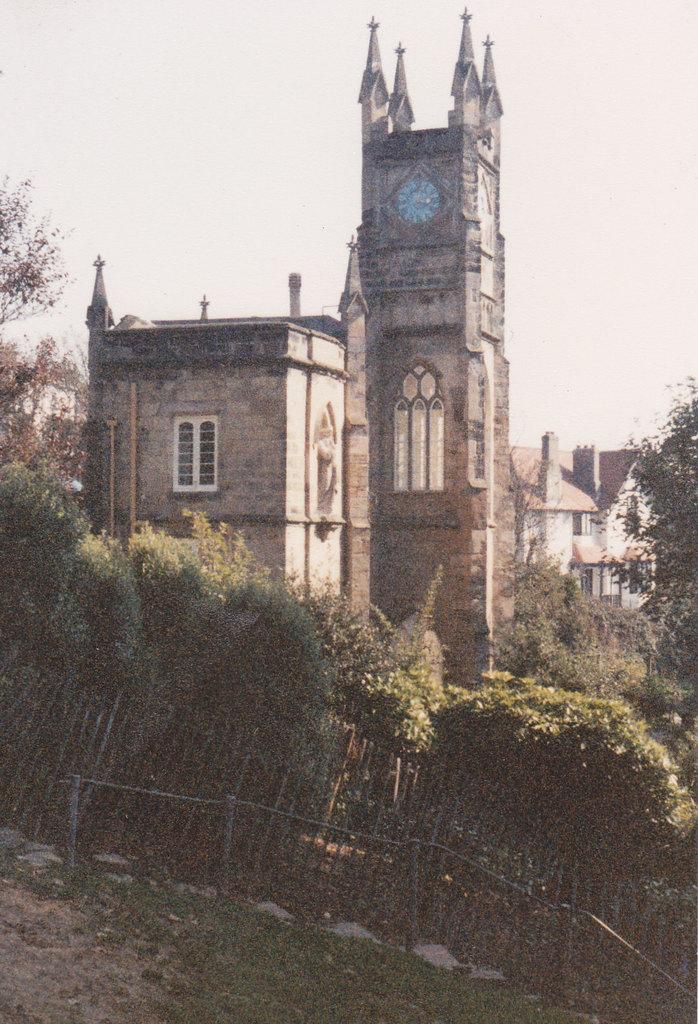What type of structures can be seen in the image? There are buildings in the image. What feature do the buildings have? The buildings have windows. What time-telling device is present in the image? There is a clock in the image. What type of barrier can be seen in the image? There is a fence in the image. What type of vegetation is present in the image? Plants, grass, and trees are present in the image. What part of the natural environment is visible in the image? The sky is visible in the image. What type of soup is being served in the image? There is no soup present in the image. How many fingers are visible in the image? There are no fingers visible in the image. 